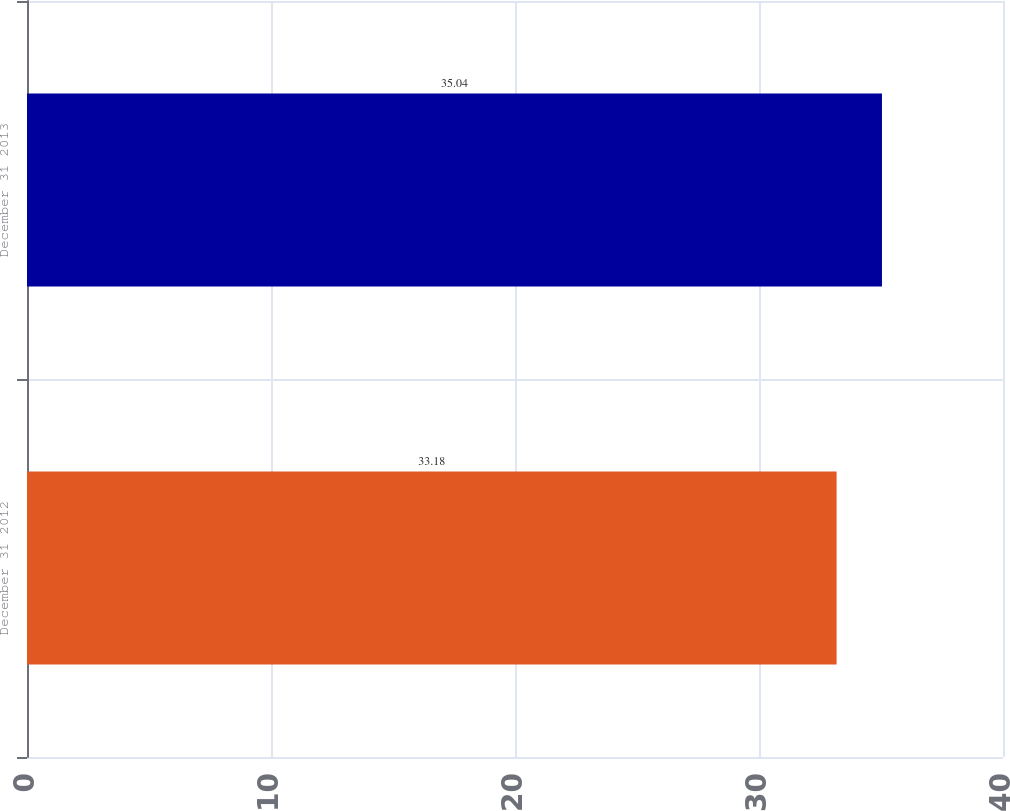<chart> <loc_0><loc_0><loc_500><loc_500><bar_chart><fcel>December 31 2012<fcel>December 31 2013<nl><fcel>33.18<fcel>35.04<nl></chart> 